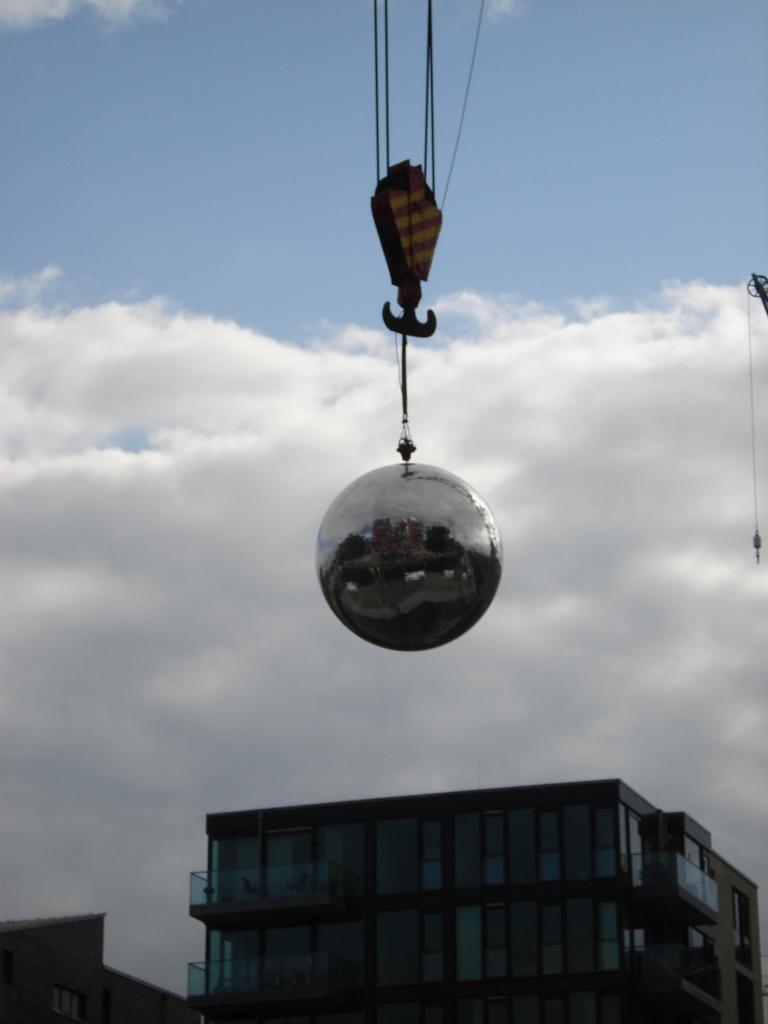How would you summarize this image in a sentence or two? In the middle of this image, there is a silver color ball held by a hanger. At the bottom of this image, there are buildings. In the background, there are clouds in the blue sky. 